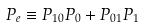<formula> <loc_0><loc_0><loc_500><loc_500>P _ { e } \equiv P _ { 1 0 } P _ { 0 } + P _ { 0 1 } P _ { 1 }</formula> 